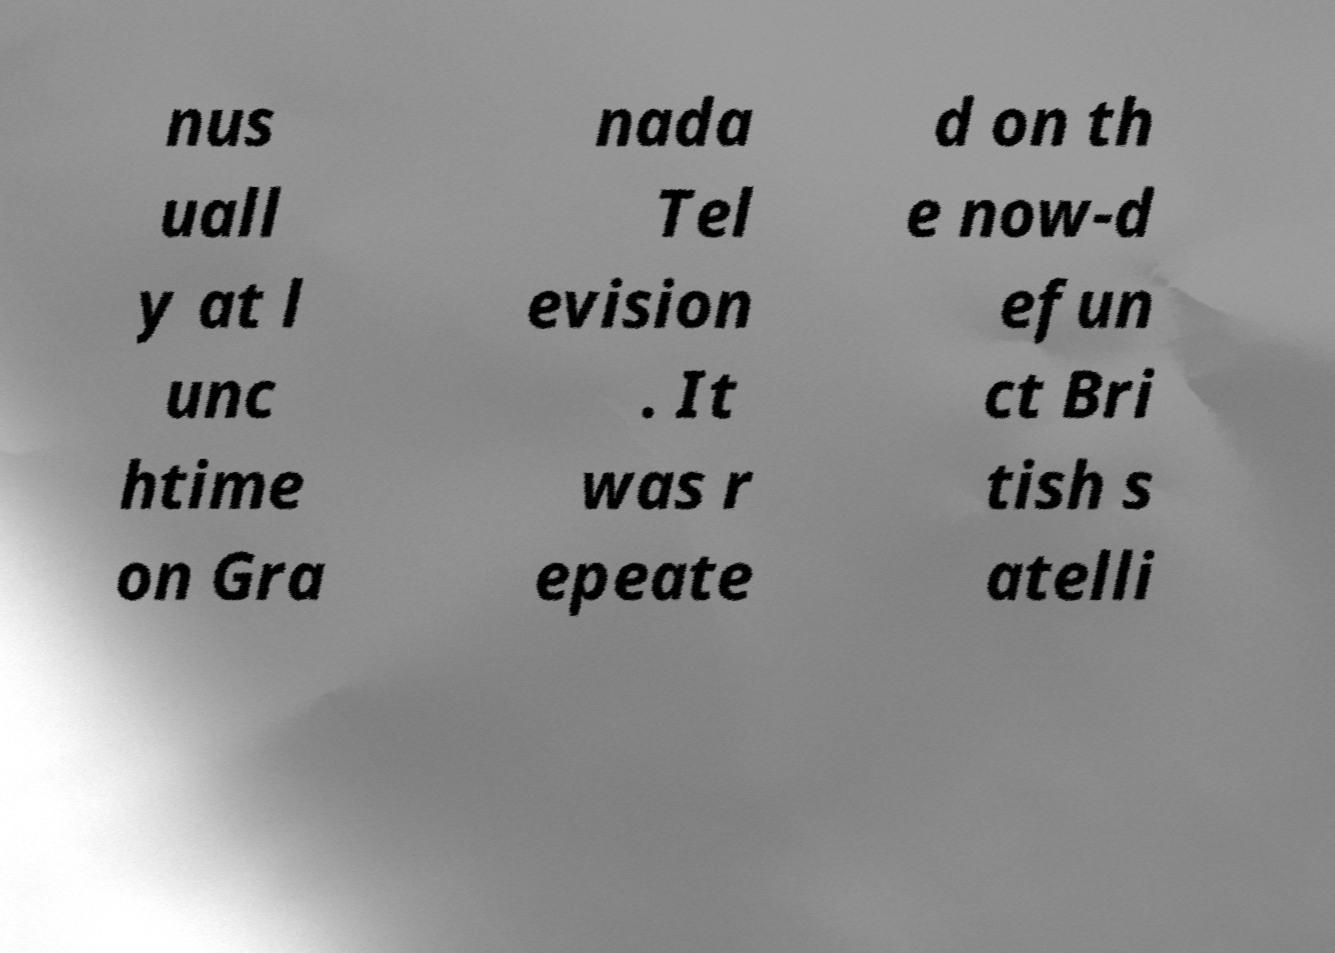Could you assist in decoding the text presented in this image and type it out clearly? nus uall y at l unc htime on Gra nada Tel evision . It was r epeate d on th e now-d efun ct Bri tish s atelli 